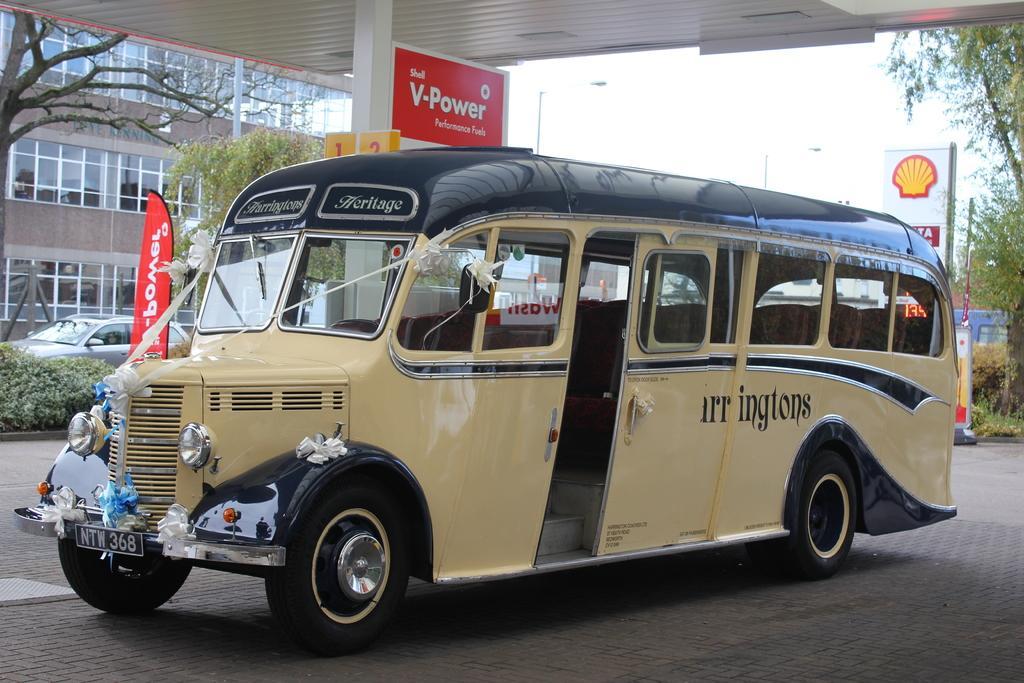Describe this image in one or two sentences. In this image there is a vehicle parked, beside the vehicle there is a banner with some text, pillar and at the top of the image there is a metal shed. In the background there is a building, a vehicle moving on the road, trees, plants, a few boards with some text, street lights and the sky. 